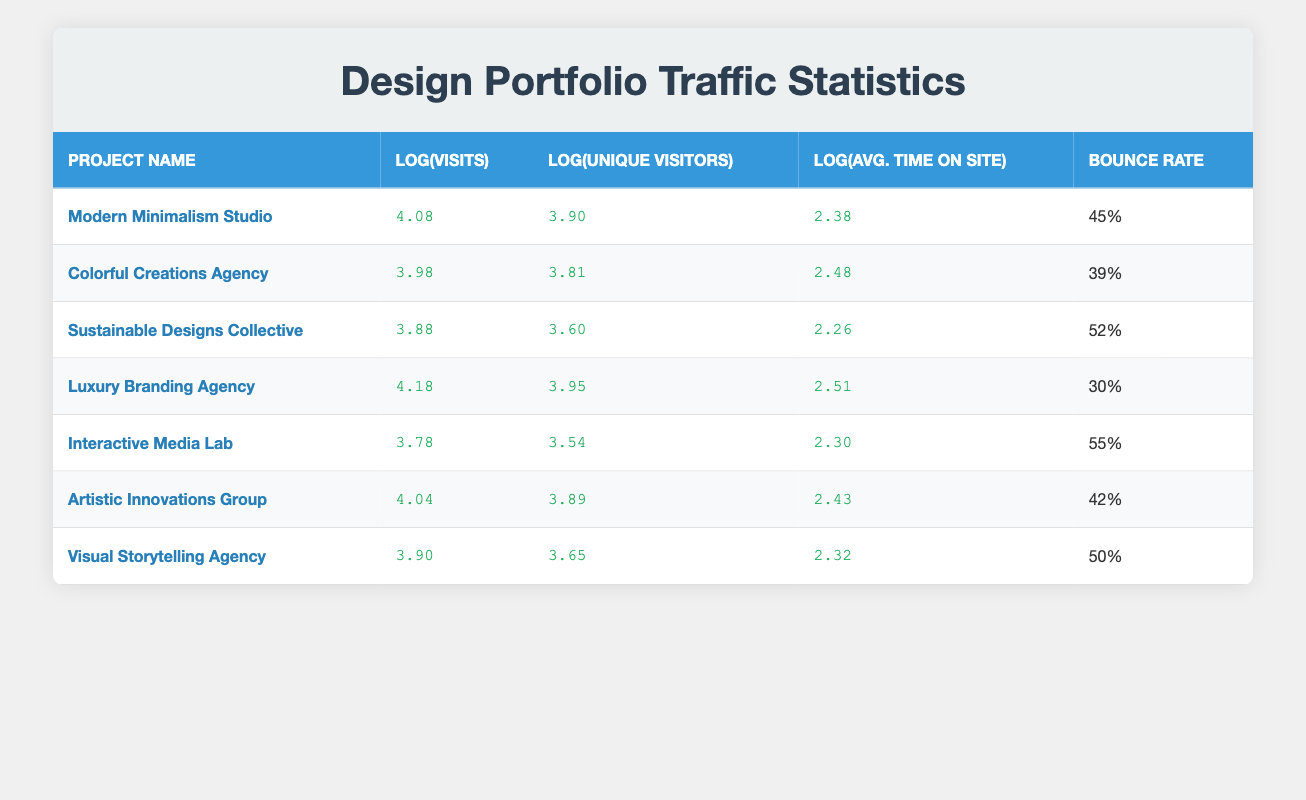What is the project with the highest number of visits? The project with the highest number of visits is "Luxury Branding Agency," which has 15000 visits.
Answer: Luxury Branding Agency What is the average bounce rate of all projects? To find the average bounce rate, sum the bounce rates of all projects (45 + 39 + 52 + 30 + 55 + 42 + 50 = 313) and divide by the number of projects (7). The average bounce rate is 313 / 7 = 44.71%.
Answer: 44.71% Does the "Sustainable Designs Collective" have a higher bounce rate than the "Interactive Media Lab"? The bounce rate for "Sustainable Designs Collective" is 52%, while for "Interactive Media Lab," it is 55%. Since 52% < 55%, the statement is false.
Answer: No Which project has the longest average time on site? The project with the longest average time on site is "Luxury Branding Agency," which has an average time of 320 seconds.
Answer: Luxury Branding Agency What is the difference in log(Visits) between the project with the highest and lowest visits? The highest log(Visits) is for the "Luxury Branding Agency" at 4.18, and the lowest is for "Interactive Media Lab" at 3.78. The difference is 4.18 - 3.78 = 0.40.
Answer: 0.40 What is the average number of unique visitors across all projects? To calculate the average unique visitors, sum all unique visitors (8000 + 6500 + 4000 + 9000 + 3500 + 7800 + 4500 = 38800) and divide by the number of projects (7). The average is 38800 / 7 = 5542.86.
Answer: 5542.86 Is it true that "Artistic Innovations Group" has more unique visitors than "Visual Storytelling Agency"? "Artistic Innovations Group" has 7800 unique visitors, while "Visual Storytelling Agency" has 4500 unique visitors. Since 7800 > 4500, the statement is true.
Answer: Yes What is the log(Avg. Time on Site) for "Colorful Creations Agency"? The log(Avg. Time on Site) for "Colorful Creations Agency" is 2.48.
Answer: 2.48 Which project has a lower number of unique visitors: "Interactive Media Lab" or "Sustainable Designs Collective"? "Interactive Media Lab" has 3500 unique visitors, and "Sustainable Designs Collective" has 4000 unique visitors. Since 3500 < 4000, "Interactive Media Lab" has fewer unique visitors.
Answer: Interactive Media Lab 